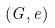Convert formula to latex. <formula><loc_0><loc_0><loc_500><loc_500>( G , e )</formula> 